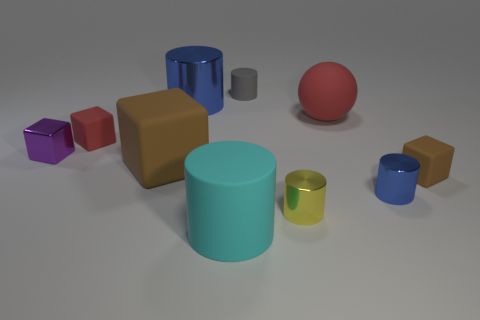What is the shape of the brown thing that is left of the brown matte thing that is on the right side of the large cylinder in front of the small purple thing? The brown object to the left of the matte brown thing on the right side of the large blue cylinder, which is in front of the small purple cube, appears to be a cube, aligning accurately with a three-dimensional square shape. 